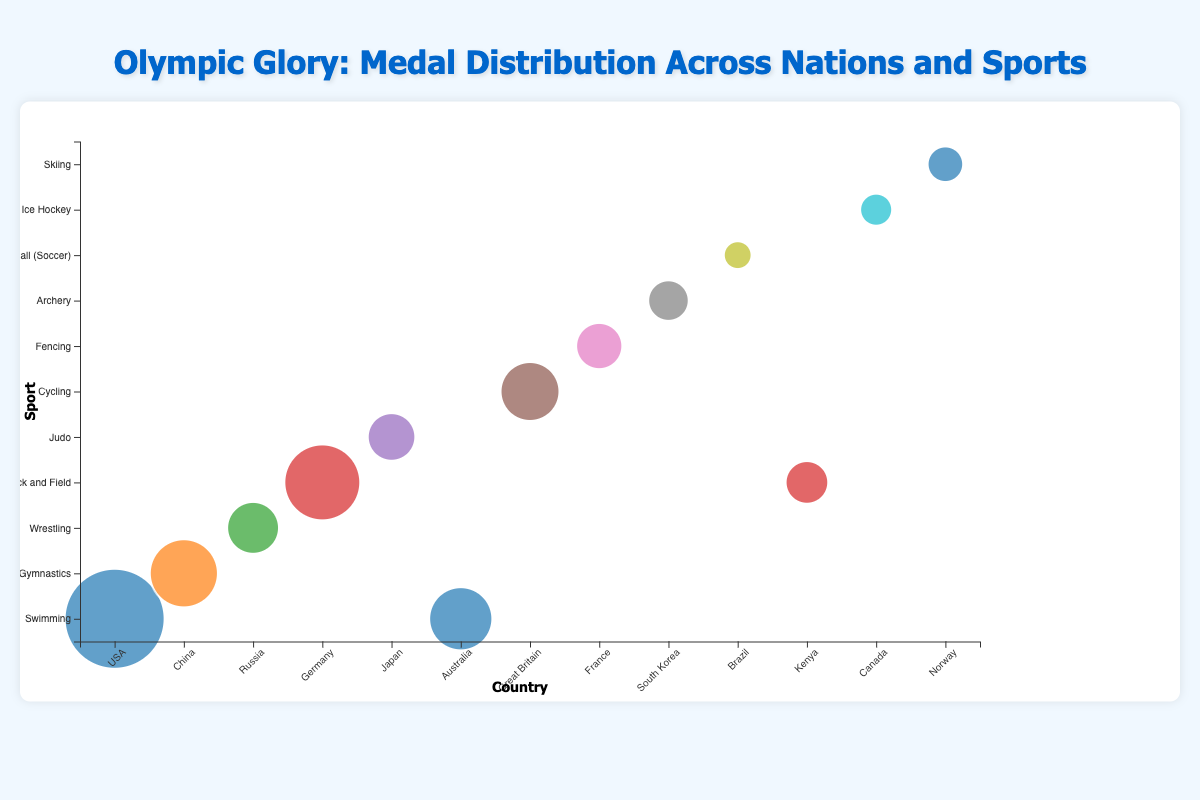What's the title of the figure? The title is displayed at the top of the figure.
Answer: Olympic Glory: Medal Distribution Across Nations and Sports How many countries are represented in the chart? Count the unique values in the 'country' axis.
Answer: 13 Which country has the largest bubble? Look for the biggest bubble in terms of size and check the corresponding country label on the x-axis.
Answer: USA How many more medals did the USA win in swimming compared to Australia? Locate the bubbles for Swimming under USA and Australia, then subtract the medals of Australia from the medals of USA. 113 - 61 = 52
Answer: 52 Which sport is associated with the smallest bubble? Identify the smallest bubble and check the corresponding sport label on the y-axis.
Answer: Football (Soccer) Which country achieved the highest number of medals in Track and Field? Find the largest bubble associated with the 'Track and Field' sport on the y-axis, and identify the corresponding country on the x-axis.
Answer: Germany How many sports does Germany have bubbles for in the chart? Locate all bubbles along the 'country' axis for Germany and count the unique sports.
Answer: 1 Which has more medals, the sum of Gymnastics medals for China or the sum of Fencing medals for France and Judo medals for Japan? Compare the Gymnastics medals for China (68) to the sum of Fencing medals for France (37) and Judo medals for Japan (39). So, 68 vs 37+39 = 76.
Answer: France and Japan combined Out of the sports listed, how many are winter sports? Identify and count the winter sports from the list of sports: Ice Hockey, Skiing.
Answer: 2 Which sport/country combination scored exactly 45 medals? Look for the bubble that indicates 45 medals and check the corresponding sport and country labels.
Answer: Wrestling/Russia 